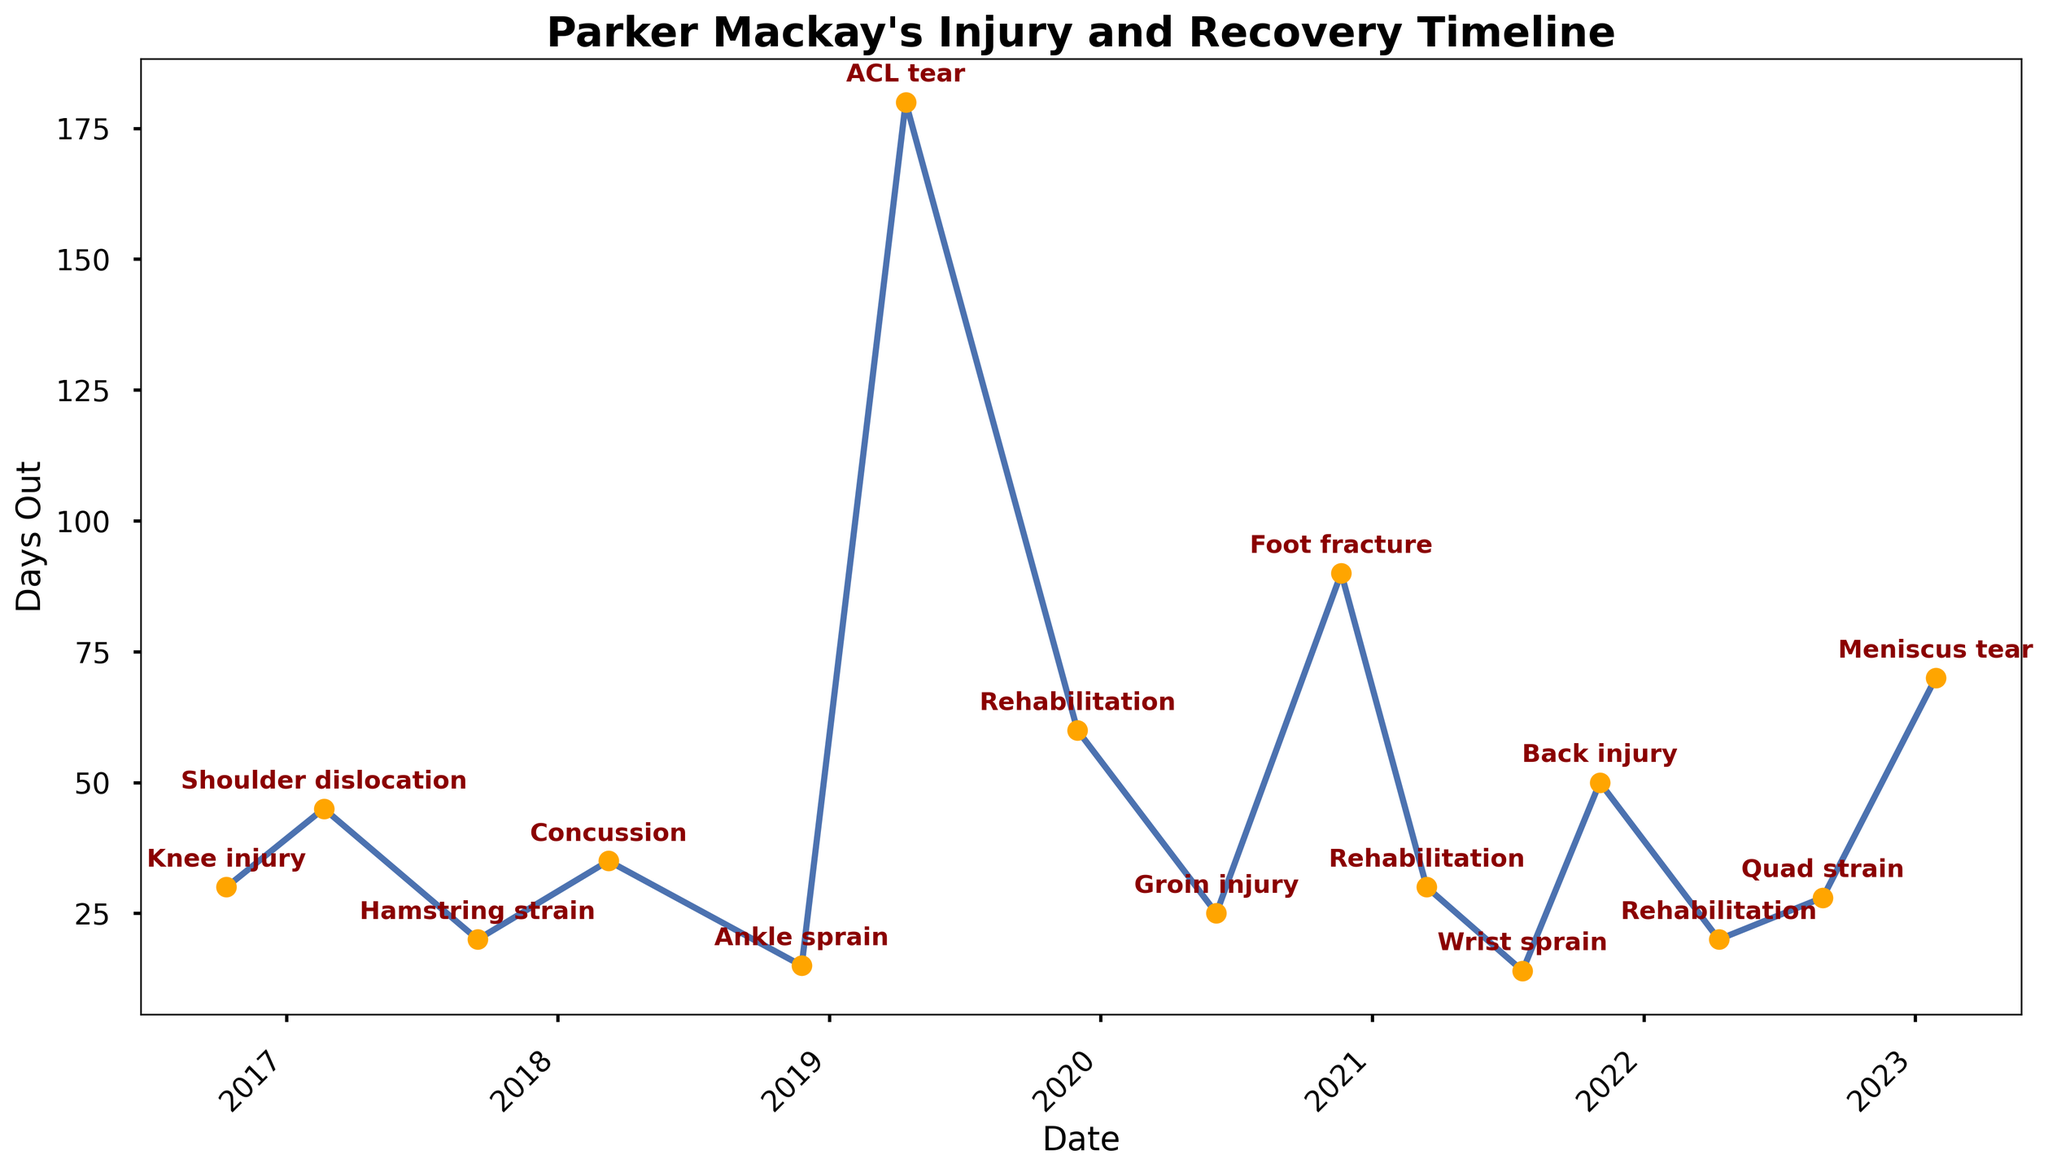Which injury kept Parker Mackay out the longest? The y-axis represents the number of days out. The highest point on the chart indicates the longest duration. Parker Mackay's "ACL tear" appears to be the highest on the y-axis.
Answer: ACL tear How many total days was Parker Mackay out due to injuries in 2019? According to the chart, Parker Mackay had two injuries in 2019: an "ACL tear" which kept him out for 180 days, and "Rehabilitation" for 60 days. Summing these (180 + 60) gives the total days out.
Answer: 240 What was the trend in his injury recovery times between 2016 and 2023? By observing the plot from left to right (2016 to 2023), you can see the trend of the number of days out fluctuating but with some very significant peaks, particularly in 2019 and 2020.
Answer: Fluctuating Which year had the least number of days Parker Mackay was out due to injuries? By checking the chart for each year and summing the days out, it appears 2021 had only 94 days out, the lowest sum. Comparing this to the other years confirms it as the least.
Answer: 2021 Compare the severity of injuries based on the time out, which injury in 2020 had Parker out longer? 2020 had "Groin injury" and "Foot fracture". The days out for "Groin injury" is 25, whereas for "Foot fracture" it is 90. "Foot fracture" kept him out longer.
Answer: Foot fracture How many times did Parker Mackay need rehabilitation during the timeline shown? By visually scanning the chart for "Rehabilitation" labels, it's noted in 2019, 2021 and 2022. This counts to three occurrences.
Answer: 3 What is the average number of days out for the injuries listed? Summing all the days out gives \(30 + 45 + 20 + 35 + 15 + 180 + 60 + 25 + 90 + 30 + 14 + 50 + 20 + 28 + 70\), which equals 712. Dividing 712 by the 15 injuries provides the average: \(712 / 15 \approx 47.47\).
Answer: 47.47 Identify the injury in 2018 that had the shortest recovery time. In 2018, the two injuries listed are "Concussion" (35 days out) and "Ankle sprain" (15 days out). The shorter recovery time belongs to "Ankle sprain".
Answer: Ankle sprain Based on the graph, did Parker Mackay’s recovery time improve after the ACL tear in 2019? After the ACL tear in 2019, Parker Mackay’s subsequent days out for injuries were primarily less than 60 days, indicating an improvement.
Answer: Yes 